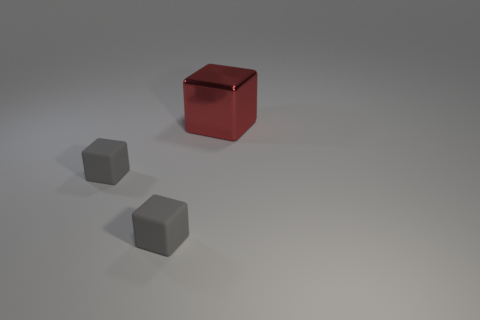Add 3 big red metal things. How many big red metal things exist? 4 Add 2 tiny matte blocks. How many objects exist? 5 Subtract all gray cubes. How many cubes are left? 1 Subtract all rubber cubes. How many cubes are left? 1 Subtract 0 yellow balls. How many objects are left? 3 Subtract 3 blocks. How many blocks are left? 0 Subtract all blue blocks. Subtract all purple cylinders. How many blocks are left? 3 Subtract all red cylinders. How many purple blocks are left? 0 Subtract all red things. Subtract all brown matte objects. How many objects are left? 2 Add 3 small gray cubes. How many small gray cubes are left? 5 